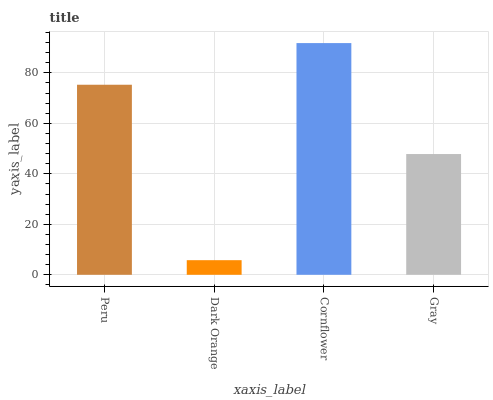Is Dark Orange the minimum?
Answer yes or no. Yes. Is Cornflower the maximum?
Answer yes or no. Yes. Is Cornflower the minimum?
Answer yes or no. No. Is Dark Orange the maximum?
Answer yes or no. No. Is Cornflower greater than Dark Orange?
Answer yes or no. Yes. Is Dark Orange less than Cornflower?
Answer yes or no. Yes. Is Dark Orange greater than Cornflower?
Answer yes or no. No. Is Cornflower less than Dark Orange?
Answer yes or no. No. Is Peru the high median?
Answer yes or no. Yes. Is Gray the low median?
Answer yes or no. Yes. Is Gray the high median?
Answer yes or no. No. Is Dark Orange the low median?
Answer yes or no. No. 